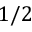Convert formula to latex. <formula><loc_0><loc_0><loc_500><loc_500>1 / 2</formula> 